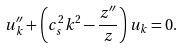Convert formula to latex. <formula><loc_0><loc_0><loc_500><loc_500>u _ { k } ^ { \prime \prime } + \left ( c _ { s } ^ { 2 } k ^ { 2 } - \frac { z ^ { \prime \prime } } { z } \right ) u _ { k } = 0 .</formula> 